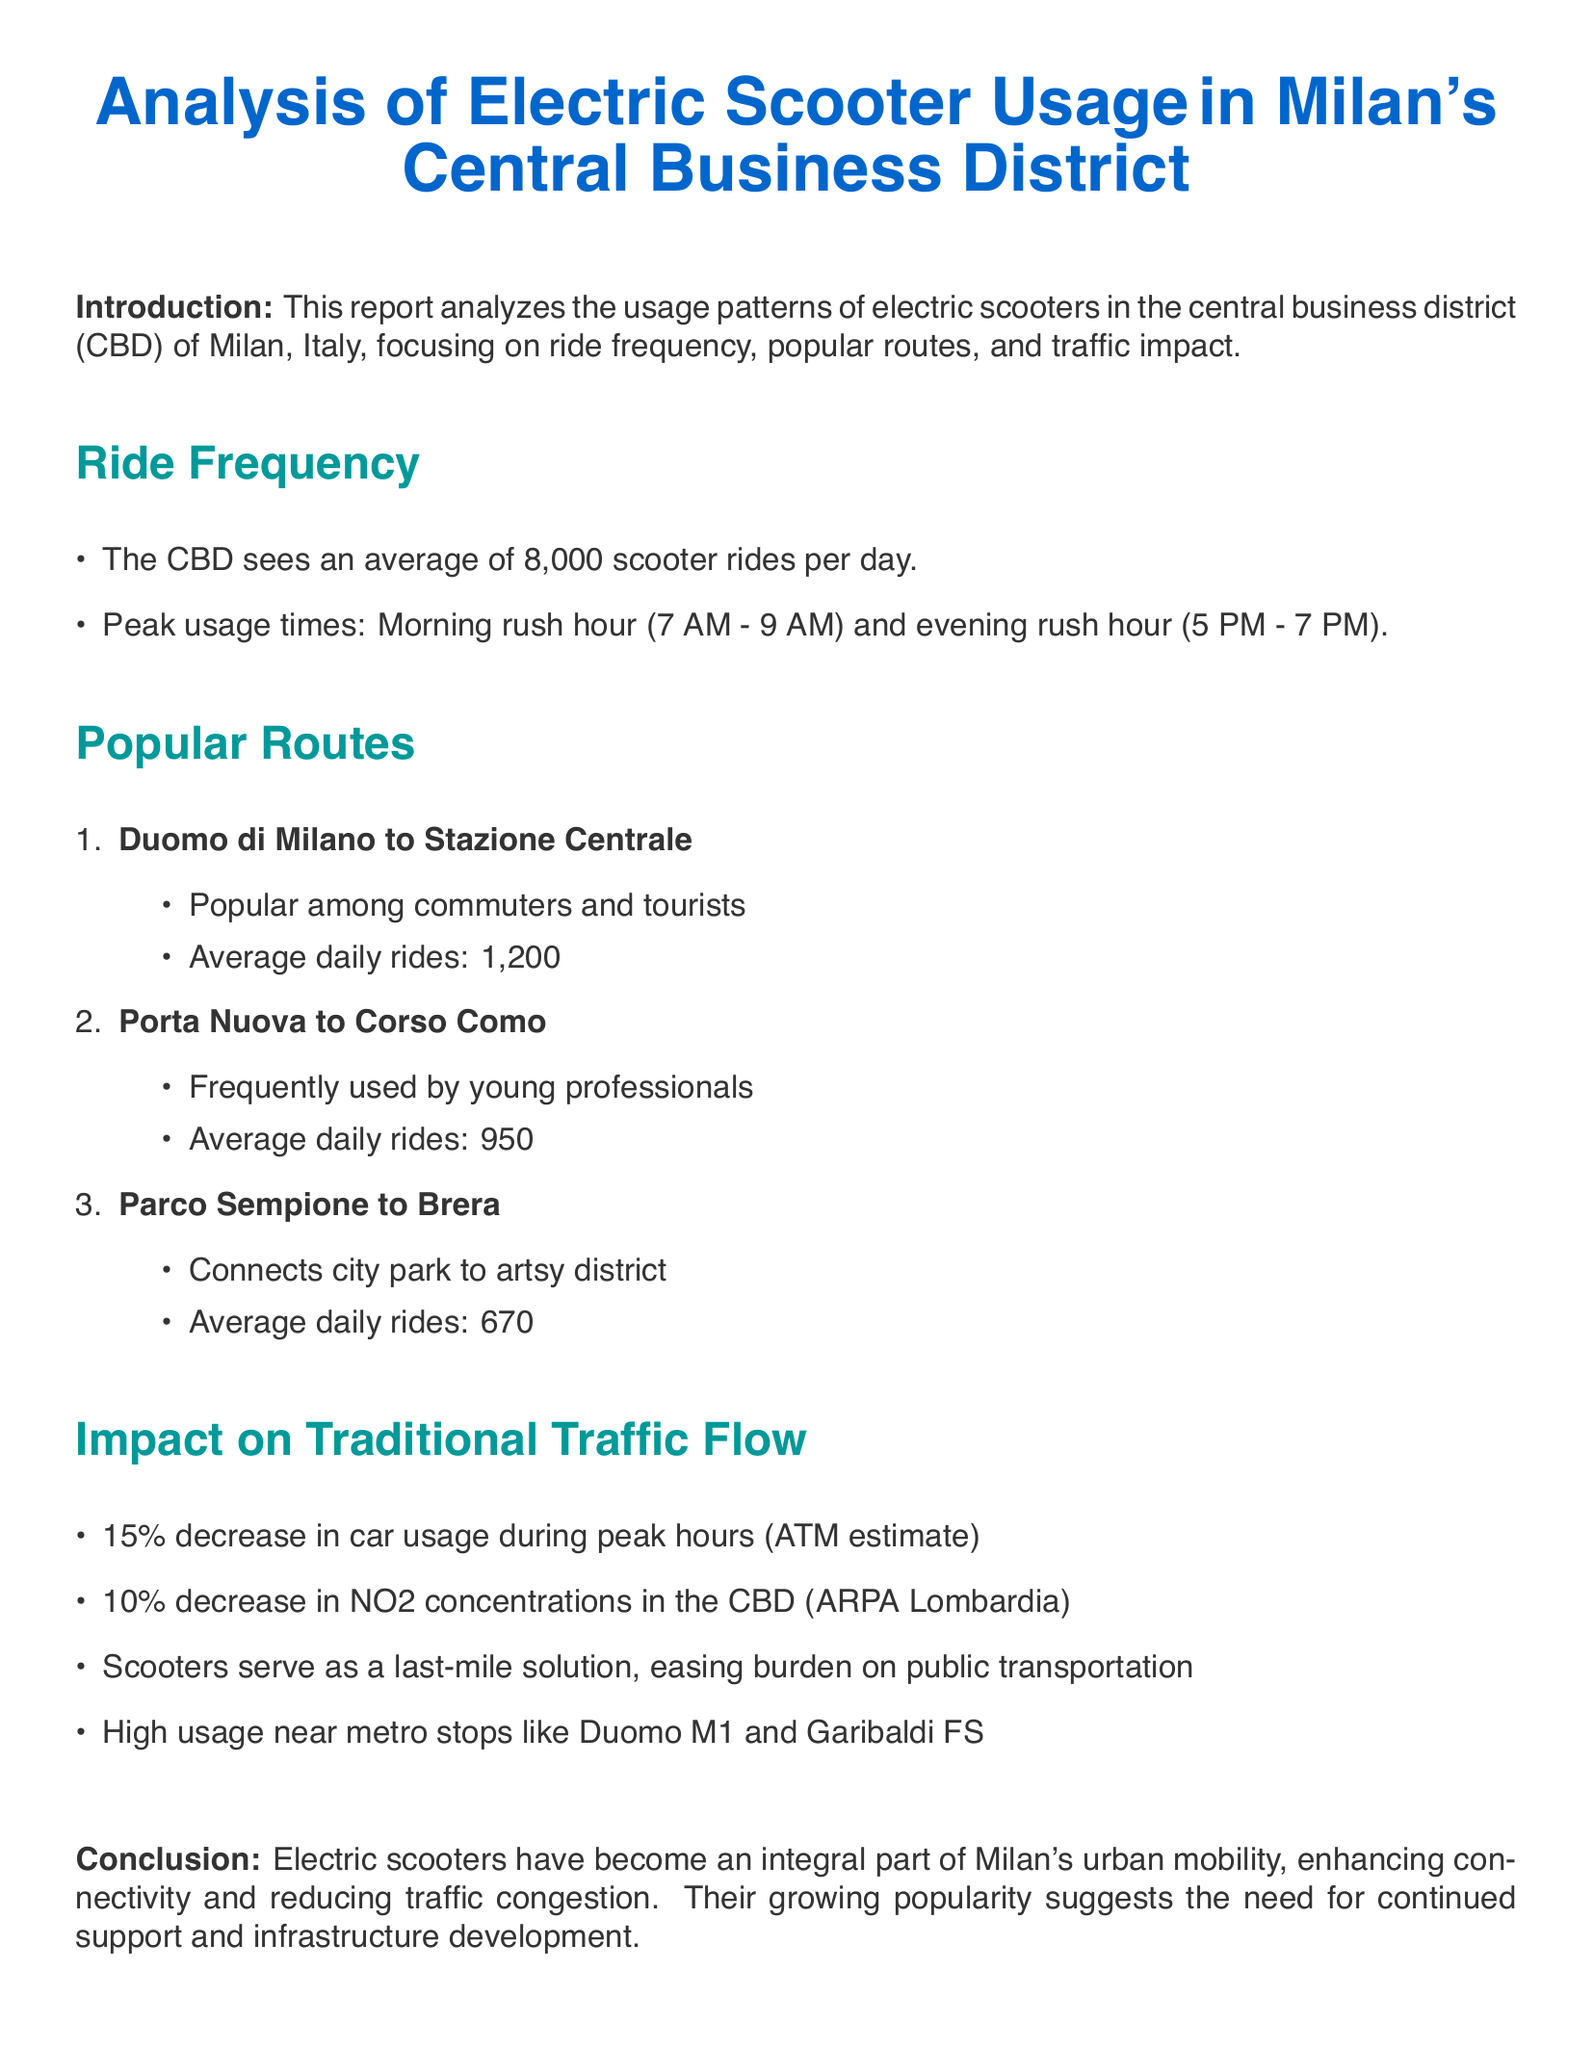What is the average number of scooter rides per day in the CBD? The average number of scooter rides in the CBD is stated in the document as 8,000.
Answer: 8,000 What are the peak usage times for electric scooters? The document specifies two peak usage times: morning rush hour and evening rush hour.
Answer: Morning rush hour and evening rush hour How many daily rides does the route from Duomo di Milano to Stazione Centrale average? The document mentions this specific route averages 1,200 daily rides.
Answer: 1,200 What percentage decrease in car usage during peak hours is estimated? According to the document, there is a 15% decrease in car usage during peak hours.
Answer: 15% Which route connects the city park to an artsy district? The document identifies the route from Parco Sempione to Brera as connecting these areas.
Answer: Parco Sempione to Brera What is the impact of electric scooters on NO2 concentrations in the CBD? The document states that there is a 10% decrease in NO2 concentrations due to scooter usage.
Answer: 10% Which metro stops see high usage of scooters? The document lists Duomo M1 and Garibaldi FS as metro stops with high scooter usage.
Answer: Duomo M1 and Garibaldi FS What conclusion does the report reach about electric scooters? The report concludes that scooters enhance connectivity and reduce traffic congestion in Milan.
Answer: Enhance connectivity and reduce traffic congestion What is a significant role of electric scooters in urban mobility? The document describes scooters as a last-mile solution that eases the burden on public transportation.
Answer: Last-mile solution 